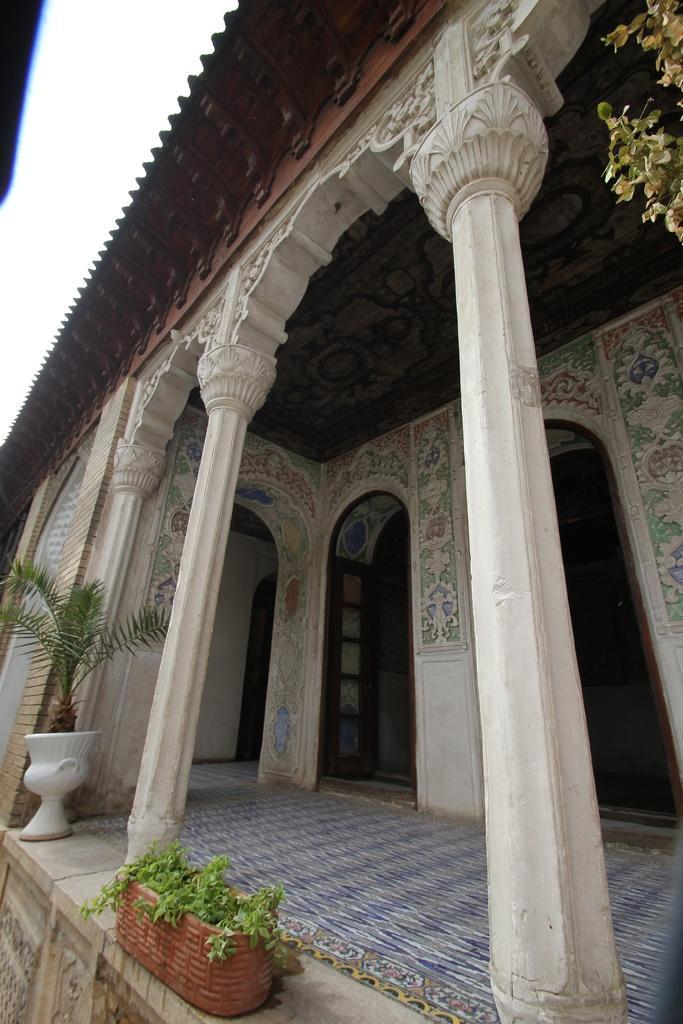Please provide a concise description of this image. In this image, I can see a house with the pillars and designs on the wall. At the bottom of the image, there are flower pots with plants, which are placed on the floor. At the top right side of the image, I can see the leaves. In the background, there is the sky. 